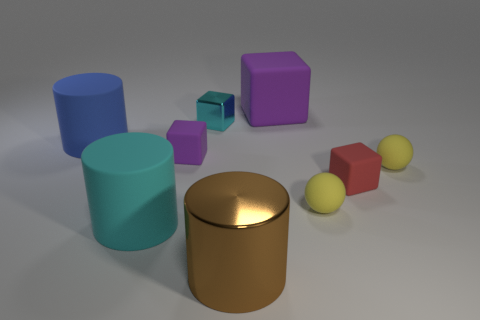There is a blue thing that is behind the big metallic cylinder; what shape is it?
Offer a very short reply. Cylinder. What number of yellow spheres have the same material as the small purple object?
Ensure brevity in your answer.  2. There is a large brown metal thing; is it the same shape as the cyan object left of the cyan metallic object?
Your answer should be very brief. Yes. There is a rubber cube that is on the left side of the matte block behind the tiny cyan thing; is there a big matte object in front of it?
Keep it short and to the point. Yes. There is a cyan object behind the tiny purple thing; what is its size?
Ensure brevity in your answer.  Small. What is the material of the cyan thing that is the same size as the red object?
Your answer should be very brief. Metal. Is the cyan metallic thing the same shape as the blue object?
Offer a terse response. No. What number of objects are either small yellow metallic cylinders or blocks that are to the right of the shiny cylinder?
Offer a terse response. 2. There is a metal thing that is to the left of the brown object; does it have the same size as the red object?
Keep it short and to the point. Yes. There is a cyan thing that is behind the blue cylinder in front of the cyan metallic object; what number of red things are in front of it?
Provide a succinct answer. 1. 